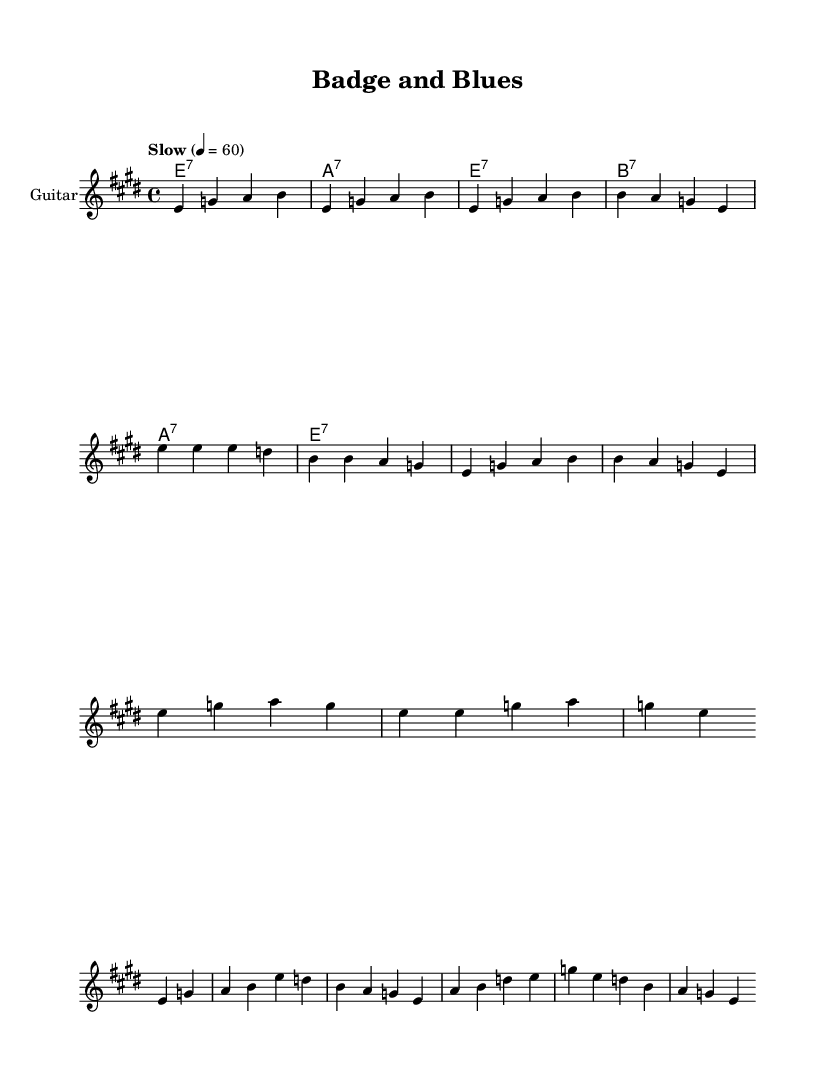What is the key signature of this music? The key signature indicated at the beginning of the sheet music is E major, which has four sharps: F#, C#, G#, and D#.
Answer: E major What is the time signature used in this composition? The time signature, noted in the sheet music, is 4/4, meaning there are four beats per measure, and the quarter note gets one beat.
Answer: 4/4 What is the tempo marking for this piece? The tempo marking appears as "Slow" with a metronome marking of quarter note equals 60, which indicates a slow pace for the music.
Answer: Slow How many measures are in the verse? Counting the grouped sections in the "melodyVerse", there are a total of 8 measures present in the verse structure.
Answer: 8 What is the main lyrical theme of the song? The lyrics describe themes of maintaining composure and strength under pressure, which ties to mental preparedness in high-pressure situations in police work.
Answer: Coping under pressure Which instrument has the primary melody in this sheet music? The staff labeled as "Guitar" is responsible for playing the primary melody throughout the composition, with additional parts for harmonica and chords listed separately.
Answer: Guitar 